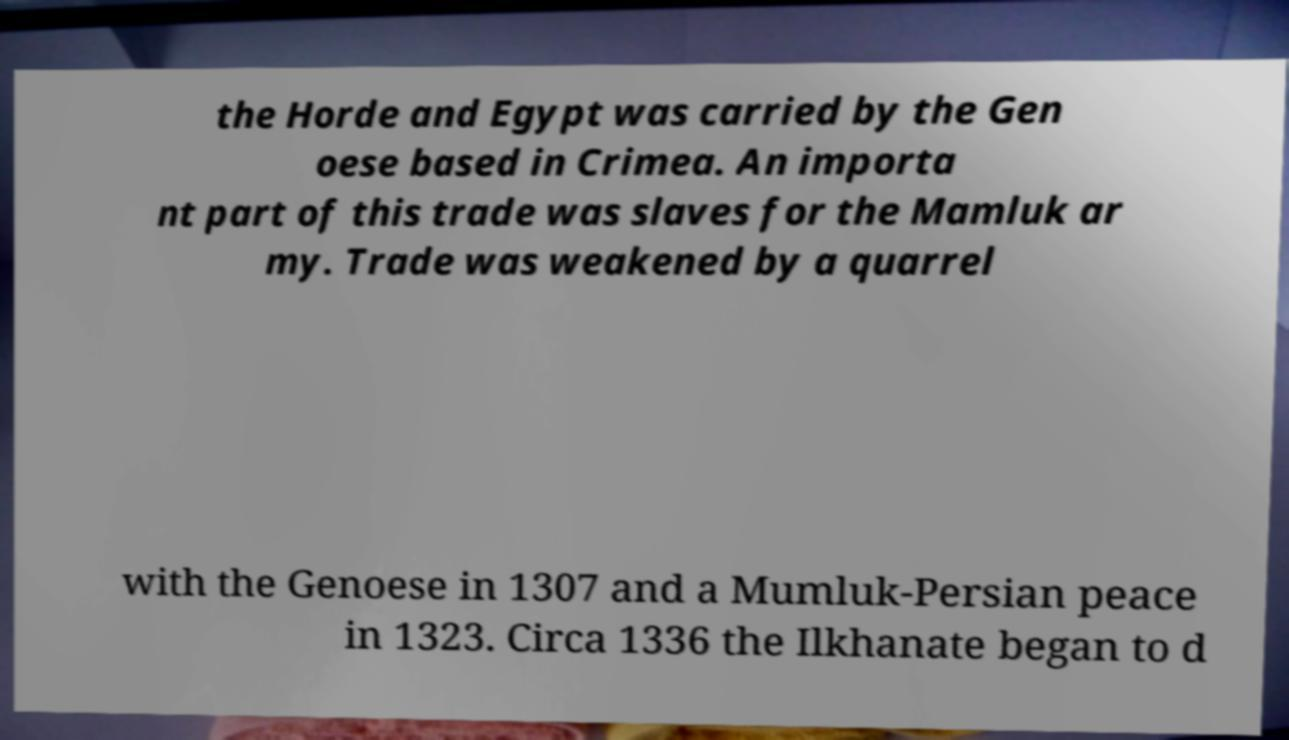Can you read and provide the text displayed in the image?This photo seems to have some interesting text. Can you extract and type it out for me? the Horde and Egypt was carried by the Gen oese based in Crimea. An importa nt part of this trade was slaves for the Mamluk ar my. Trade was weakened by a quarrel with the Genoese in 1307 and a Mumluk-Persian peace in 1323. Circa 1336 the Ilkhanate began to d 